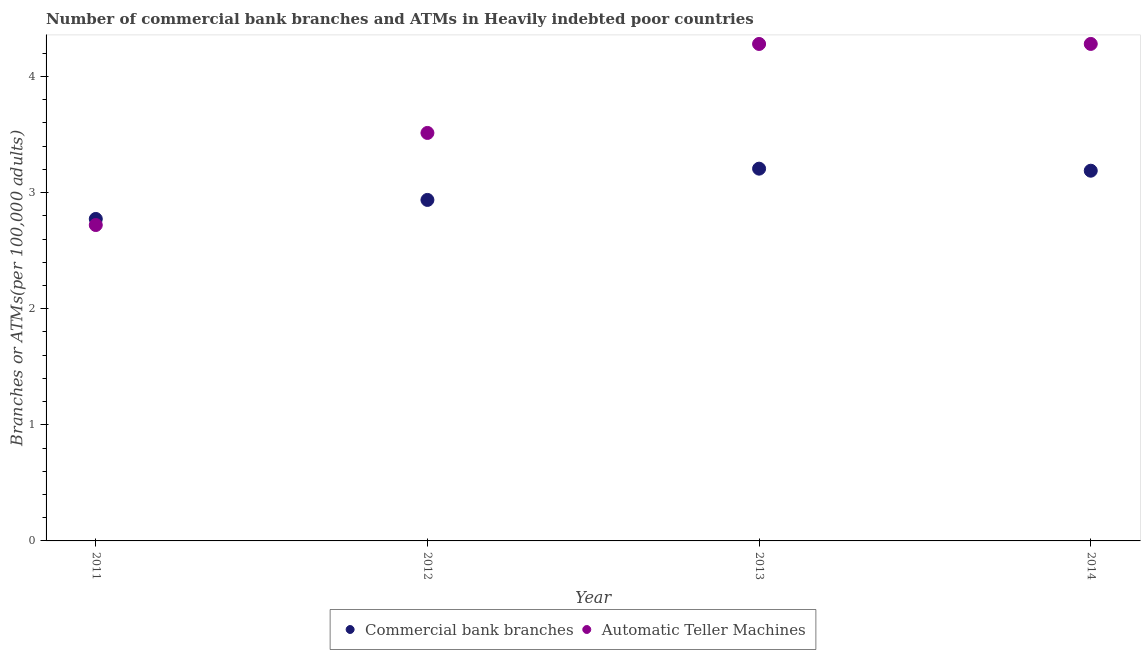What is the number of commercal bank branches in 2014?
Provide a succinct answer. 3.19. Across all years, what is the maximum number of atms?
Your answer should be compact. 4.28. Across all years, what is the minimum number of commercal bank branches?
Your answer should be compact. 2.77. In which year was the number of commercal bank branches maximum?
Offer a terse response. 2013. In which year was the number of atms minimum?
Offer a very short reply. 2011. What is the total number of atms in the graph?
Your response must be concise. 14.79. What is the difference between the number of atms in 2012 and that in 2014?
Keep it short and to the point. -0.77. What is the difference between the number of commercal bank branches in 2014 and the number of atms in 2013?
Offer a terse response. -1.09. What is the average number of atms per year?
Give a very brief answer. 3.7. In the year 2014, what is the difference between the number of atms and number of commercal bank branches?
Offer a very short reply. 1.09. What is the ratio of the number of commercal bank branches in 2012 to that in 2013?
Make the answer very short. 0.92. Is the number of commercal bank branches in 2011 less than that in 2012?
Make the answer very short. Yes. Is the difference between the number of atms in 2012 and 2014 greater than the difference between the number of commercal bank branches in 2012 and 2014?
Provide a short and direct response. No. What is the difference between the highest and the second highest number of commercal bank branches?
Your answer should be very brief. 0.02. What is the difference between the highest and the lowest number of atms?
Keep it short and to the point. 1.56. In how many years, is the number of atms greater than the average number of atms taken over all years?
Provide a short and direct response. 2. How many dotlines are there?
Your response must be concise. 2. Are the values on the major ticks of Y-axis written in scientific E-notation?
Offer a terse response. No. Does the graph contain any zero values?
Offer a very short reply. No. How many legend labels are there?
Offer a terse response. 2. What is the title of the graph?
Give a very brief answer. Number of commercial bank branches and ATMs in Heavily indebted poor countries. What is the label or title of the X-axis?
Your answer should be compact. Year. What is the label or title of the Y-axis?
Your response must be concise. Branches or ATMs(per 100,0 adults). What is the Branches or ATMs(per 100,000 adults) of Commercial bank branches in 2011?
Keep it short and to the point. 2.77. What is the Branches or ATMs(per 100,000 adults) of Automatic Teller Machines in 2011?
Make the answer very short. 2.72. What is the Branches or ATMs(per 100,000 adults) of Commercial bank branches in 2012?
Provide a succinct answer. 2.94. What is the Branches or ATMs(per 100,000 adults) of Automatic Teller Machines in 2012?
Keep it short and to the point. 3.51. What is the Branches or ATMs(per 100,000 adults) in Commercial bank branches in 2013?
Your answer should be very brief. 3.21. What is the Branches or ATMs(per 100,000 adults) in Automatic Teller Machines in 2013?
Your response must be concise. 4.28. What is the Branches or ATMs(per 100,000 adults) of Commercial bank branches in 2014?
Offer a terse response. 3.19. What is the Branches or ATMs(per 100,000 adults) of Automatic Teller Machines in 2014?
Your answer should be compact. 4.28. Across all years, what is the maximum Branches or ATMs(per 100,000 adults) in Commercial bank branches?
Keep it short and to the point. 3.21. Across all years, what is the maximum Branches or ATMs(per 100,000 adults) of Automatic Teller Machines?
Provide a short and direct response. 4.28. Across all years, what is the minimum Branches or ATMs(per 100,000 adults) in Commercial bank branches?
Offer a terse response. 2.77. Across all years, what is the minimum Branches or ATMs(per 100,000 adults) in Automatic Teller Machines?
Your answer should be very brief. 2.72. What is the total Branches or ATMs(per 100,000 adults) in Commercial bank branches in the graph?
Offer a terse response. 12.1. What is the total Branches or ATMs(per 100,000 adults) in Automatic Teller Machines in the graph?
Your answer should be compact. 14.79. What is the difference between the Branches or ATMs(per 100,000 adults) in Commercial bank branches in 2011 and that in 2012?
Your answer should be compact. -0.16. What is the difference between the Branches or ATMs(per 100,000 adults) of Automatic Teller Machines in 2011 and that in 2012?
Make the answer very short. -0.79. What is the difference between the Branches or ATMs(per 100,000 adults) of Commercial bank branches in 2011 and that in 2013?
Offer a very short reply. -0.43. What is the difference between the Branches or ATMs(per 100,000 adults) of Automatic Teller Machines in 2011 and that in 2013?
Your answer should be very brief. -1.56. What is the difference between the Branches or ATMs(per 100,000 adults) in Commercial bank branches in 2011 and that in 2014?
Your answer should be compact. -0.42. What is the difference between the Branches or ATMs(per 100,000 adults) in Automatic Teller Machines in 2011 and that in 2014?
Give a very brief answer. -1.56. What is the difference between the Branches or ATMs(per 100,000 adults) in Commercial bank branches in 2012 and that in 2013?
Your answer should be compact. -0.27. What is the difference between the Branches or ATMs(per 100,000 adults) of Automatic Teller Machines in 2012 and that in 2013?
Make the answer very short. -0.77. What is the difference between the Branches or ATMs(per 100,000 adults) in Commercial bank branches in 2012 and that in 2014?
Your answer should be very brief. -0.25. What is the difference between the Branches or ATMs(per 100,000 adults) of Automatic Teller Machines in 2012 and that in 2014?
Make the answer very short. -0.77. What is the difference between the Branches or ATMs(per 100,000 adults) in Commercial bank branches in 2013 and that in 2014?
Offer a terse response. 0.02. What is the difference between the Branches or ATMs(per 100,000 adults) in Automatic Teller Machines in 2013 and that in 2014?
Your answer should be compact. -0. What is the difference between the Branches or ATMs(per 100,000 adults) in Commercial bank branches in 2011 and the Branches or ATMs(per 100,000 adults) in Automatic Teller Machines in 2012?
Make the answer very short. -0.74. What is the difference between the Branches or ATMs(per 100,000 adults) in Commercial bank branches in 2011 and the Branches or ATMs(per 100,000 adults) in Automatic Teller Machines in 2013?
Make the answer very short. -1.51. What is the difference between the Branches or ATMs(per 100,000 adults) of Commercial bank branches in 2011 and the Branches or ATMs(per 100,000 adults) of Automatic Teller Machines in 2014?
Make the answer very short. -1.51. What is the difference between the Branches or ATMs(per 100,000 adults) in Commercial bank branches in 2012 and the Branches or ATMs(per 100,000 adults) in Automatic Teller Machines in 2013?
Provide a short and direct response. -1.34. What is the difference between the Branches or ATMs(per 100,000 adults) in Commercial bank branches in 2012 and the Branches or ATMs(per 100,000 adults) in Automatic Teller Machines in 2014?
Provide a short and direct response. -1.34. What is the difference between the Branches or ATMs(per 100,000 adults) in Commercial bank branches in 2013 and the Branches or ATMs(per 100,000 adults) in Automatic Teller Machines in 2014?
Provide a succinct answer. -1.07. What is the average Branches or ATMs(per 100,000 adults) in Commercial bank branches per year?
Offer a very short reply. 3.03. What is the average Branches or ATMs(per 100,000 adults) of Automatic Teller Machines per year?
Your response must be concise. 3.7. In the year 2011, what is the difference between the Branches or ATMs(per 100,000 adults) of Commercial bank branches and Branches or ATMs(per 100,000 adults) of Automatic Teller Machines?
Your answer should be very brief. 0.05. In the year 2012, what is the difference between the Branches or ATMs(per 100,000 adults) in Commercial bank branches and Branches or ATMs(per 100,000 adults) in Automatic Teller Machines?
Keep it short and to the point. -0.58. In the year 2013, what is the difference between the Branches or ATMs(per 100,000 adults) of Commercial bank branches and Branches or ATMs(per 100,000 adults) of Automatic Teller Machines?
Give a very brief answer. -1.07. In the year 2014, what is the difference between the Branches or ATMs(per 100,000 adults) of Commercial bank branches and Branches or ATMs(per 100,000 adults) of Automatic Teller Machines?
Your answer should be very brief. -1.09. What is the ratio of the Branches or ATMs(per 100,000 adults) in Commercial bank branches in 2011 to that in 2012?
Ensure brevity in your answer.  0.94. What is the ratio of the Branches or ATMs(per 100,000 adults) in Automatic Teller Machines in 2011 to that in 2012?
Make the answer very short. 0.77. What is the ratio of the Branches or ATMs(per 100,000 adults) of Commercial bank branches in 2011 to that in 2013?
Keep it short and to the point. 0.86. What is the ratio of the Branches or ATMs(per 100,000 adults) of Automatic Teller Machines in 2011 to that in 2013?
Provide a short and direct response. 0.64. What is the ratio of the Branches or ATMs(per 100,000 adults) of Commercial bank branches in 2011 to that in 2014?
Ensure brevity in your answer.  0.87. What is the ratio of the Branches or ATMs(per 100,000 adults) in Automatic Teller Machines in 2011 to that in 2014?
Provide a succinct answer. 0.64. What is the ratio of the Branches or ATMs(per 100,000 adults) of Commercial bank branches in 2012 to that in 2013?
Make the answer very short. 0.92. What is the ratio of the Branches or ATMs(per 100,000 adults) of Automatic Teller Machines in 2012 to that in 2013?
Make the answer very short. 0.82. What is the ratio of the Branches or ATMs(per 100,000 adults) in Commercial bank branches in 2012 to that in 2014?
Your answer should be very brief. 0.92. What is the ratio of the Branches or ATMs(per 100,000 adults) of Automatic Teller Machines in 2012 to that in 2014?
Provide a succinct answer. 0.82. What is the ratio of the Branches or ATMs(per 100,000 adults) of Automatic Teller Machines in 2013 to that in 2014?
Your response must be concise. 1. What is the difference between the highest and the second highest Branches or ATMs(per 100,000 adults) of Commercial bank branches?
Offer a terse response. 0.02. What is the difference between the highest and the lowest Branches or ATMs(per 100,000 adults) of Commercial bank branches?
Your response must be concise. 0.43. What is the difference between the highest and the lowest Branches or ATMs(per 100,000 adults) in Automatic Teller Machines?
Your response must be concise. 1.56. 